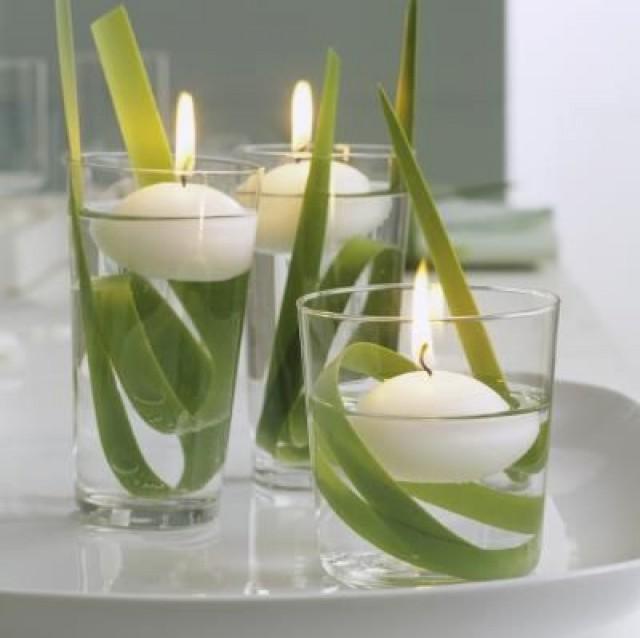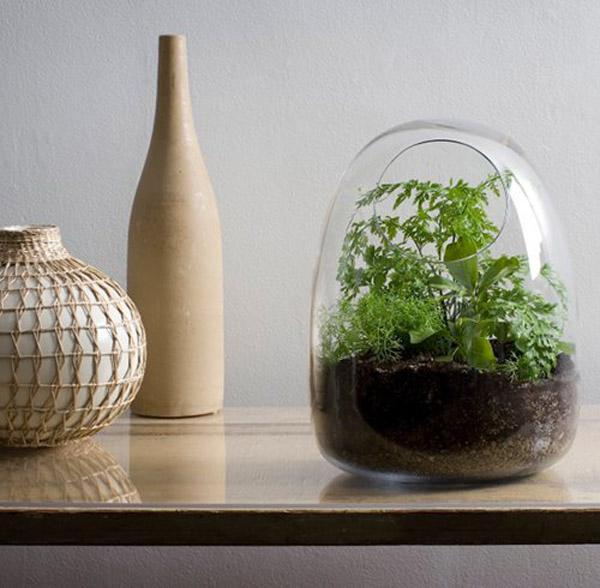The first image is the image on the left, the second image is the image on the right. For the images shown, is this caption "To the right, it appears as though one branch is held within a vase." true? Answer yes or no. No. 